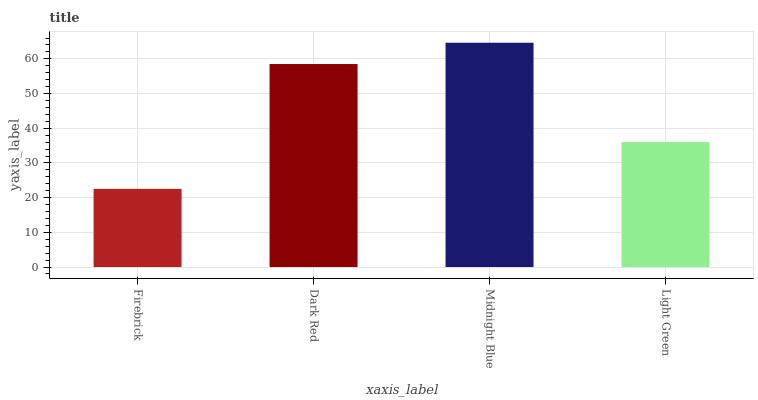Is Firebrick the minimum?
Answer yes or no. Yes. Is Midnight Blue the maximum?
Answer yes or no. Yes. Is Dark Red the minimum?
Answer yes or no. No. Is Dark Red the maximum?
Answer yes or no. No. Is Dark Red greater than Firebrick?
Answer yes or no. Yes. Is Firebrick less than Dark Red?
Answer yes or no. Yes. Is Firebrick greater than Dark Red?
Answer yes or no. No. Is Dark Red less than Firebrick?
Answer yes or no. No. Is Dark Red the high median?
Answer yes or no. Yes. Is Light Green the low median?
Answer yes or no. Yes. Is Midnight Blue the high median?
Answer yes or no. No. Is Firebrick the low median?
Answer yes or no. No. 